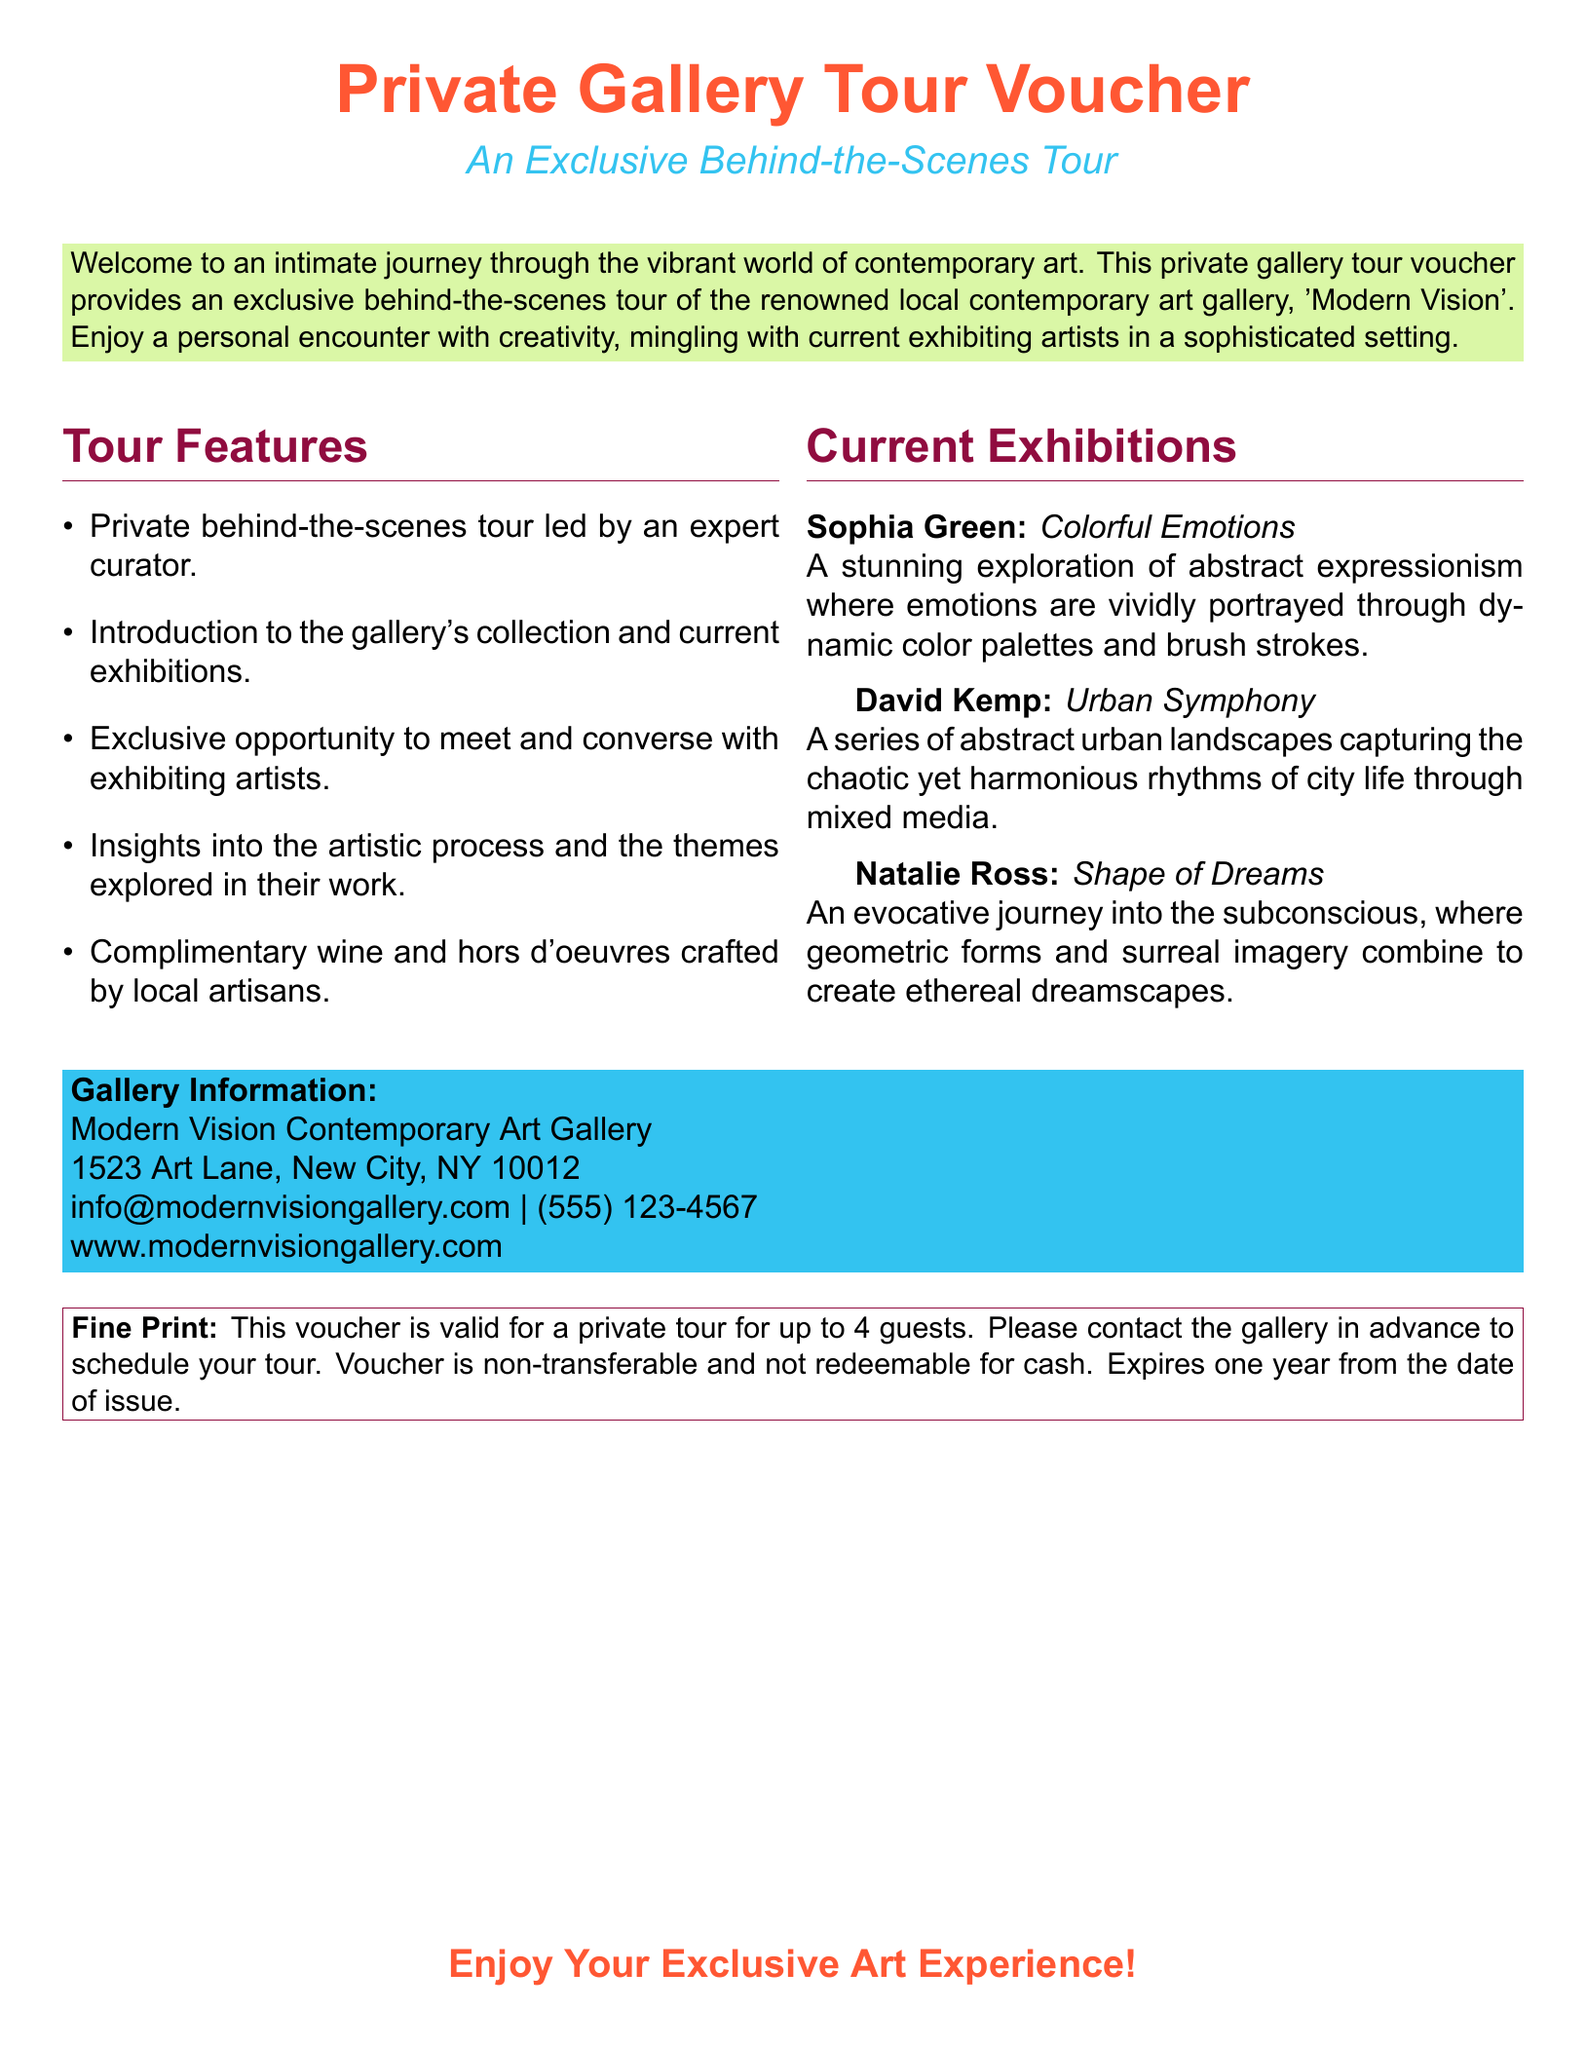What is the name of the gallery? The document states the name of the gallery as 'Modern Vision'.
Answer: Modern Vision How many guests can this voucher accommodate? The document specifies that the voucher is valid for a private tour for up to 4 guests.
Answer: 4 guests What is the theme of Sophia Green's exhibition? The document describes Sophia Green's exhibition theme as an exploration of abstract expressionism.
Answer: Abstract expressionism What is included with the tour? The voucher mentions that complimentary wine and hors d'oeuvres crafted by local artisans are included with the tour.
Answer: Wine and hors d'oeuvres What is the expiration period of the voucher? The fine print indicates that the voucher expires one year from the date of issue.
Answer: One year Who can you meet during the tour? The document notes that you have the opportunity to meet and converse with exhibiting artists during the tour.
Answer: Exhibiting artists What does David Kemp's exhibition focus on? The document states that David Kemp's exhibition captures the rhythms of city life through mixed media.
Answer: Urban landscapes What color is the main text of the voucher? The document indicates that the main color of the text is orange (hex code FF5733).
Answer: Orange 